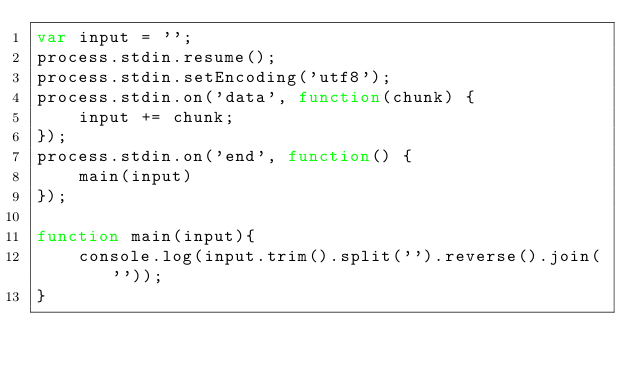Convert code to text. <code><loc_0><loc_0><loc_500><loc_500><_JavaScript_>var input = '';
process.stdin.resume();
process.stdin.setEncoding('utf8');
process.stdin.on('data', function(chunk) {
    input += chunk;
});
process.stdin.on('end', function() {
    main(input)
});

function main(input){
    console.log(input.trim().split('').reverse().join(''));
}</code> 